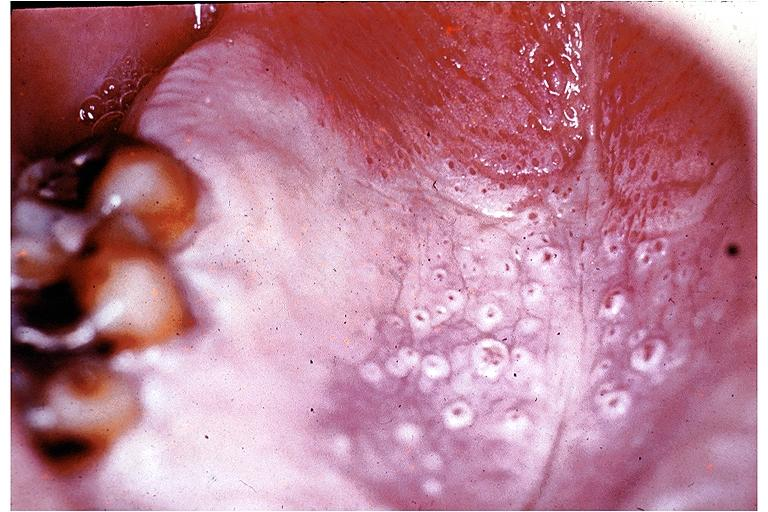s oral present?
Answer the question using a single word or phrase. Yes 